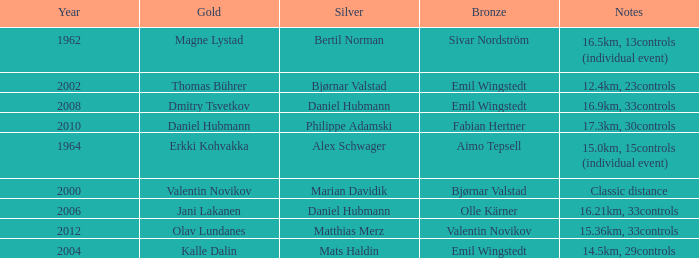WHAT IS THE YEAR WITH A BRONZE OF AIMO TEPSELL? 1964.0. 